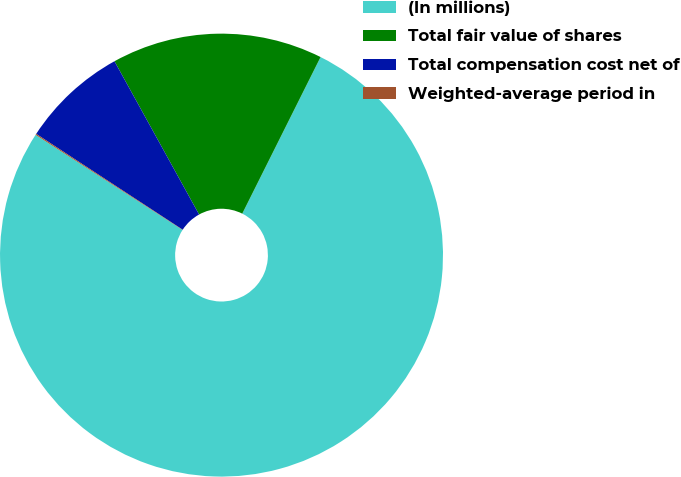<chart> <loc_0><loc_0><loc_500><loc_500><pie_chart><fcel>(In millions)<fcel>Total fair value of shares<fcel>Total compensation cost net of<fcel>Weighted-average period in<nl><fcel>76.76%<fcel>15.41%<fcel>7.75%<fcel>0.08%<nl></chart> 